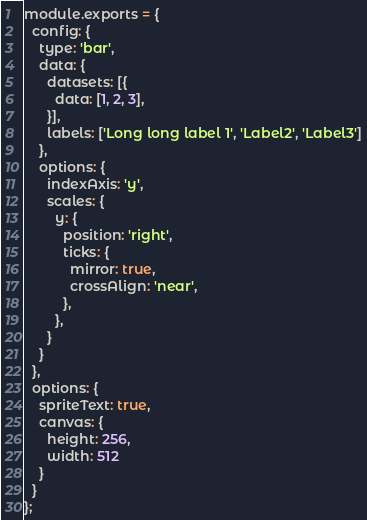<code> <loc_0><loc_0><loc_500><loc_500><_JavaScript_>module.exports = {
  config: {
    type: 'bar',
    data: {
      datasets: [{
        data: [1, 2, 3],
      }],
      labels: ['Long long label 1', 'Label2', 'Label3']
    },
    options: {
      indexAxis: 'y',
      scales: {
        y: {
          position: 'right',
          ticks: {
            mirror: true,
            crossAlign: 'near',
          },
        },
      }
    }
  },
  options: {
    spriteText: true,
    canvas: {
      height: 256,
      width: 512
    }
  }
};
</code> 